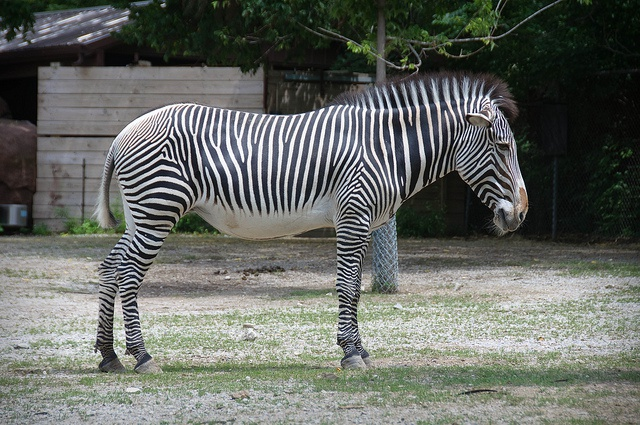Describe the objects in this image and their specific colors. I can see a zebra in black, gray, darkgray, and lightgray tones in this image. 